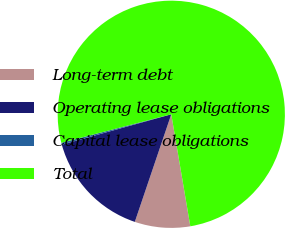Convert chart to OTSL. <chart><loc_0><loc_0><loc_500><loc_500><pie_chart><fcel>Long-term debt<fcel>Operating lease obligations<fcel>Capital lease obligations<fcel>Total<nl><fcel>7.88%<fcel>15.49%<fcel>0.27%<fcel>76.35%<nl></chart> 